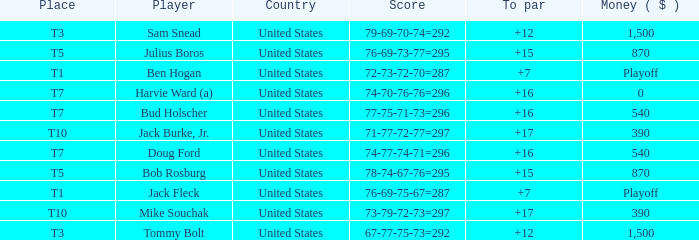Which money has player Jack Fleck with t1 place? Playoff. Parse the full table. {'header': ['Place', 'Player', 'Country', 'Score', 'To par', 'Money ( $ )'], 'rows': [['T3', 'Sam Snead', 'United States', '79-69-70-74=292', '+12', '1,500'], ['T5', 'Julius Boros', 'United States', '76-69-73-77=295', '+15', '870'], ['T1', 'Ben Hogan', 'United States', '72-73-72-70=287', '+7', 'Playoff'], ['T7', 'Harvie Ward (a)', 'United States', '74-70-76-76=296', '+16', '0'], ['T7', 'Bud Holscher', 'United States', '77-75-71-73=296', '+16', '540'], ['T10', 'Jack Burke, Jr.', 'United States', '71-77-72-77=297', '+17', '390'], ['T7', 'Doug Ford', 'United States', '74-77-74-71=296', '+16', '540'], ['T5', 'Bob Rosburg', 'United States', '78-74-67-76=295', '+15', '870'], ['T1', 'Jack Fleck', 'United States', '76-69-75-67=287', '+7', 'Playoff'], ['T10', 'Mike Souchak', 'United States', '73-79-72-73=297', '+17', '390'], ['T3', 'Tommy Bolt', 'United States', '67-77-75-73=292', '+12', '1,500']]} 